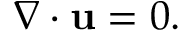Convert formula to latex. <formula><loc_0><loc_0><loc_500><loc_500>{ \nabla \cdot u } = 0 .</formula> 